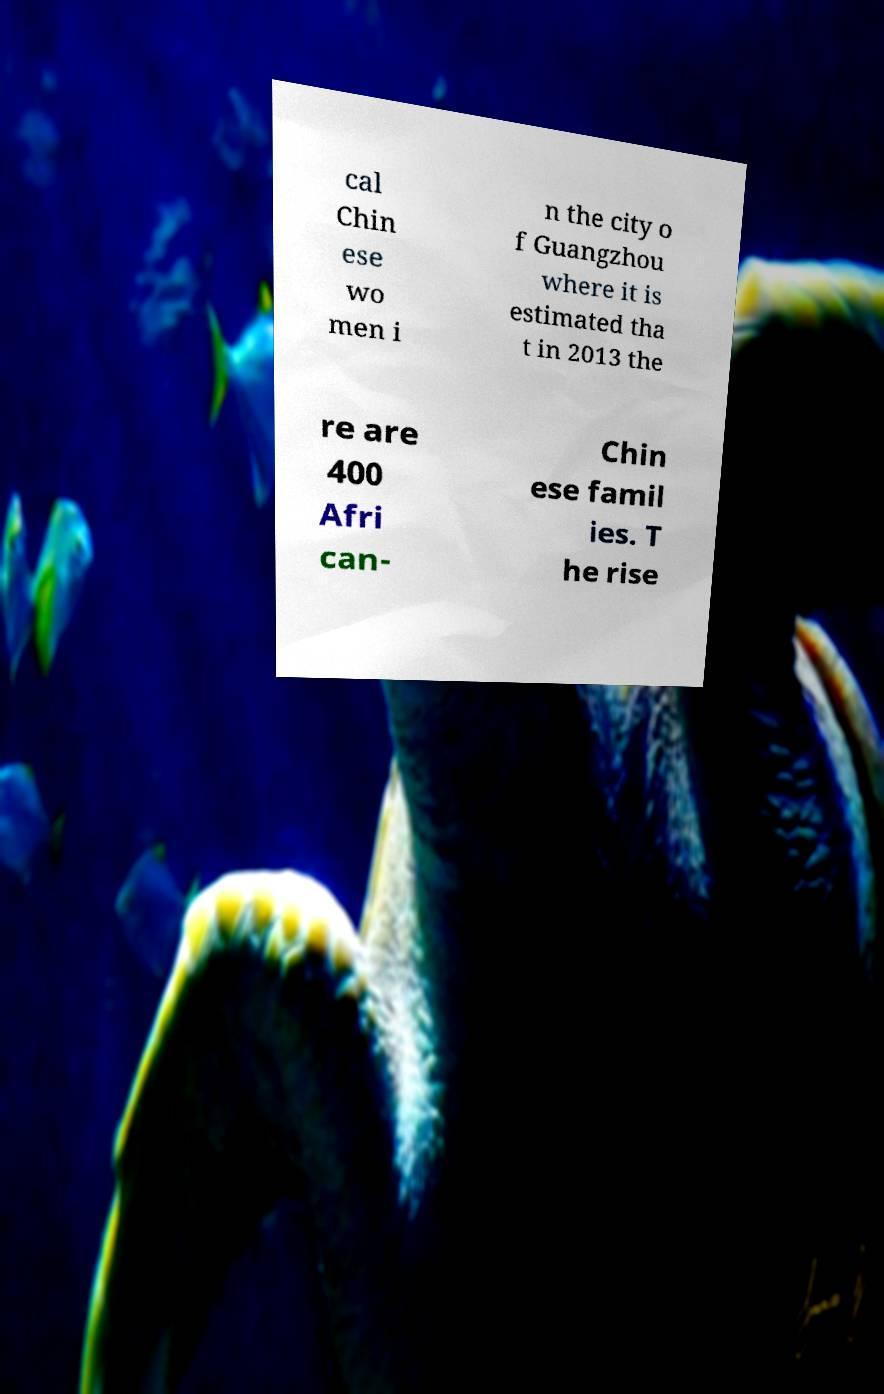Could you extract and type out the text from this image? cal Chin ese wo men i n the city o f Guangzhou where it is estimated tha t in 2013 the re are 400 Afri can- Chin ese famil ies. T he rise 